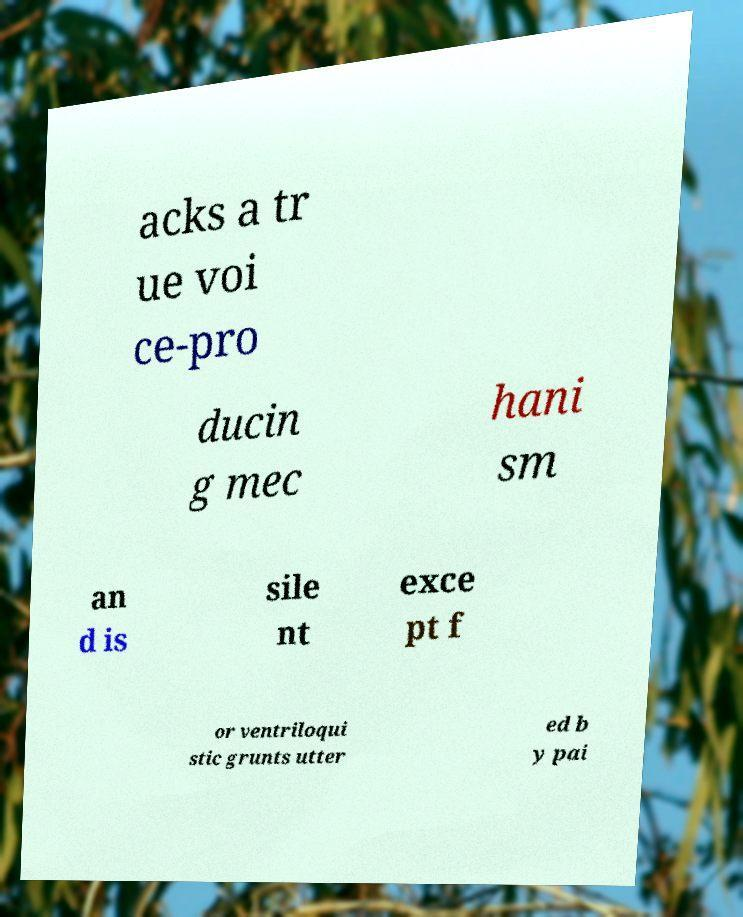Please identify and transcribe the text found in this image. acks a tr ue voi ce-pro ducin g mec hani sm an d is sile nt exce pt f or ventriloqui stic grunts utter ed b y pai 